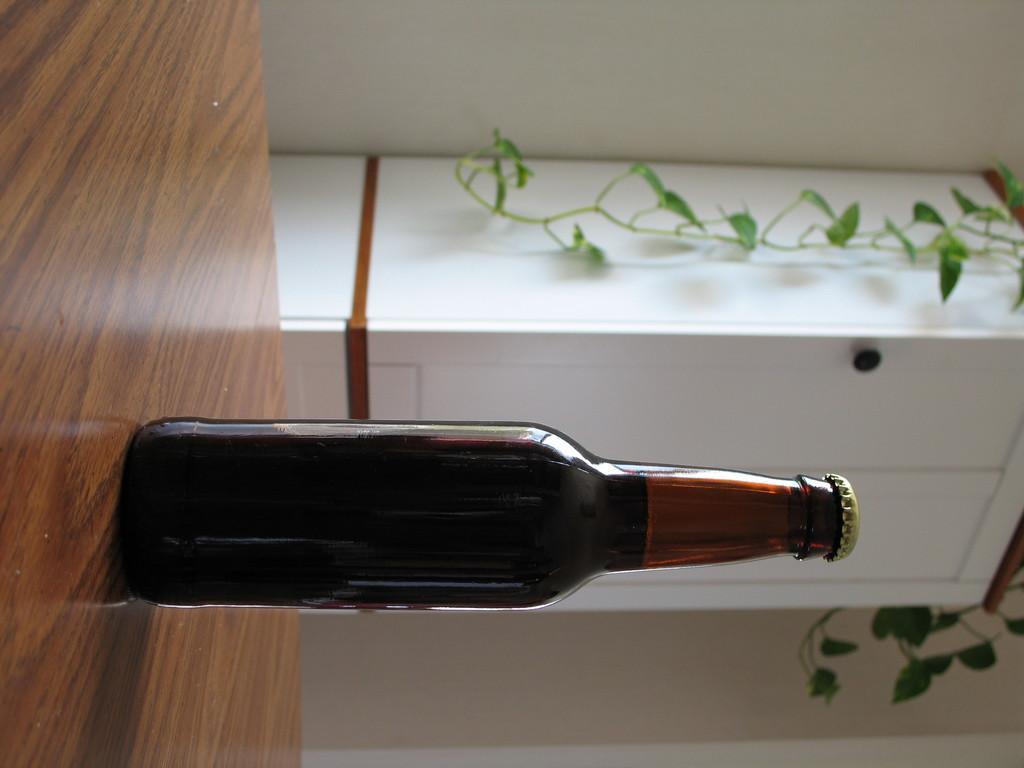Can you describe this image briefly? In this picture there is a bottle, placed on a table. In the background there is a plant, cupboard and a wall here. 